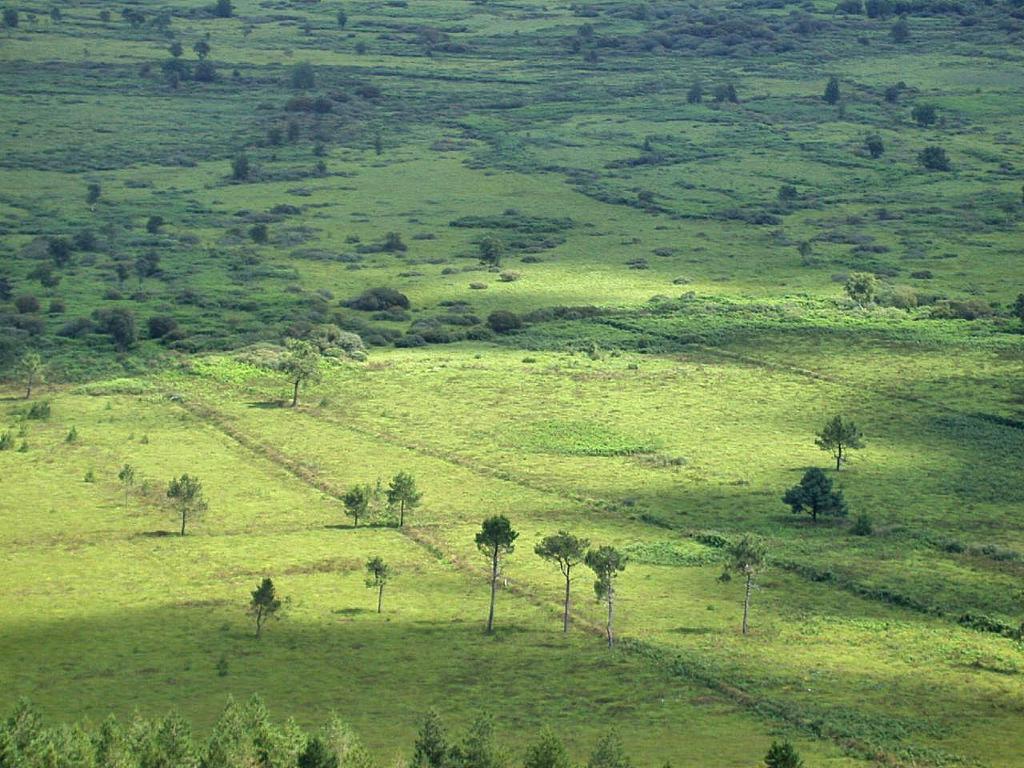Can you describe this image briefly? This picture is clicked outside and we can see the green grass, plants and trees. 